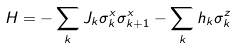Convert formula to latex. <formula><loc_0><loc_0><loc_500><loc_500>H = - \sum _ { k } J _ { k } \sigma _ { k } ^ { x } \sigma _ { k + 1 } ^ { x } - \sum _ { k } h _ { k } \sigma _ { k } ^ { z }</formula> 